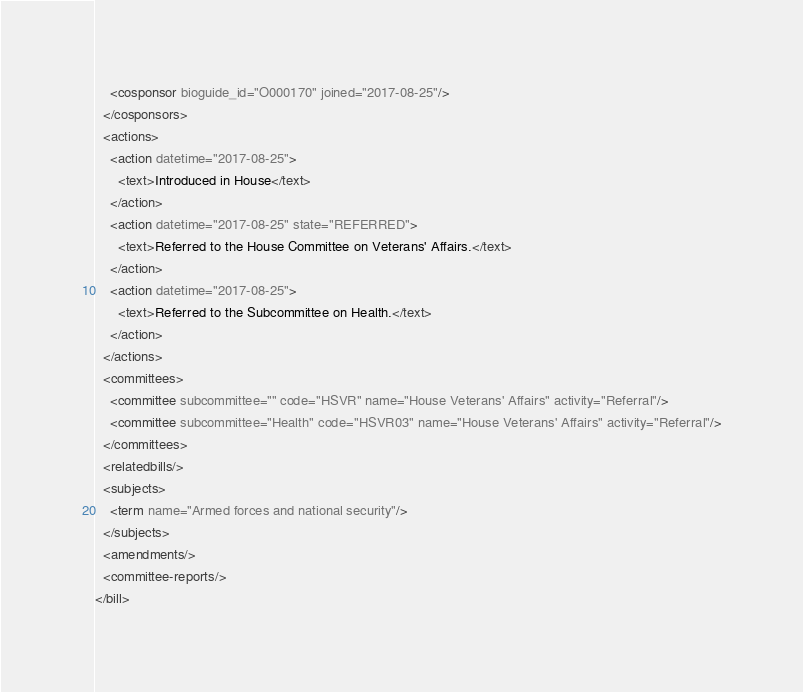<code> <loc_0><loc_0><loc_500><loc_500><_XML_>    <cosponsor bioguide_id="O000170" joined="2017-08-25"/>
  </cosponsors>
  <actions>
    <action datetime="2017-08-25">
      <text>Introduced in House</text>
    </action>
    <action datetime="2017-08-25" state="REFERRED">
      <text>Referred to the House Committee on Veterans' Affairs.</text>
    </action>
    <action datetime="2017-08-25">
      <text>Referred to the Subcommittee on Health.</text>
    </action>
  </actions>
  <committees>
    <committee subcommittee="" code="HSVR" name="House Veterans' Affairs" activity="Referral"/>
    <committee subcommittee="Health" code="HSVR03" name="House Veterans' Affairs" activity="Referral"/>
  </committees>
  <relatedbills/>
  <subjects>
    <term name="Armed forces and national security"/>
  </subjects>
  <amendments/>
  <committee-reports/>
</bill>
</code> 